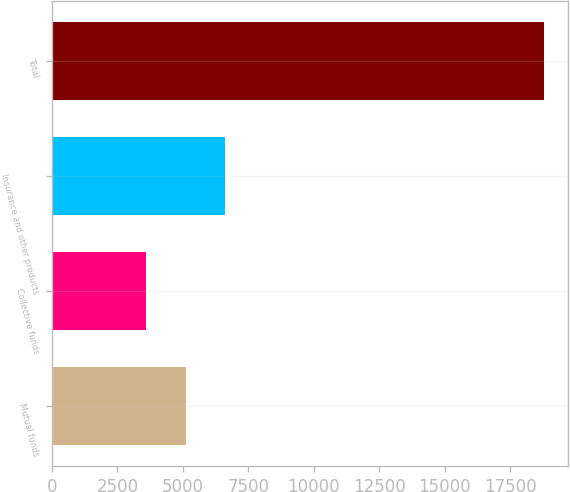<chart> <loc_0><loc_0><loc_500><loc_500><bar_chart><fcel>Mutual funds<fcel>Collective funds<fcel>Insurance and other products<fcel>Total<nl><fcel>5101.5<fcel>3580<fcel>6623<fcel>18795<nl></chart> 